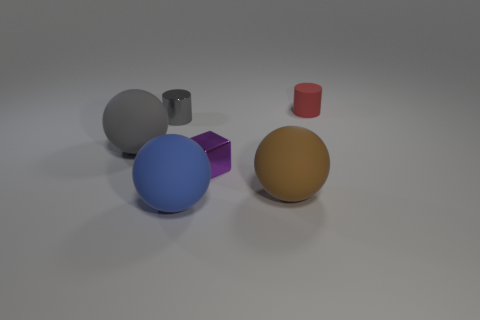Is there any other thing of the same color as the metal cylinder?
Offer a terse response. Yes. There is another tiny thing that is made of the same material as the tiny purple object; what shape is it?
Offer a terse response. Cylinder. Is the large thing that is right of the tiny purple cube made of the same material as the small purple block?
Provide a succinct answer. No. There is a big rubber thing that is the same color as the metallic cylinder; what is its shape?
Your answer should be very brief. Sphere. Is the color of the small metallic object that is to the left of the big blue thing the same as the large sphere behind the tiny metal cube?
Ensure brevity in your answer.  Yes. How many things are both behind the large brown sphere and in front of the red matte object?
Provide a short and direct response. 3. What is the large brown object made of?
Provide a succinct answer. Rubber. What shape is the gray metal object that is the same size as the red matte cylinder?
Give a very brief answer. Cylinder. Are the gray object behind the gray rubber thing and the tiny object in front of the large gray rubber object made of the same material?
Keep it short and to the point. Yes. What number of big brown matte balls are there?
Make the answer very short. 1. 